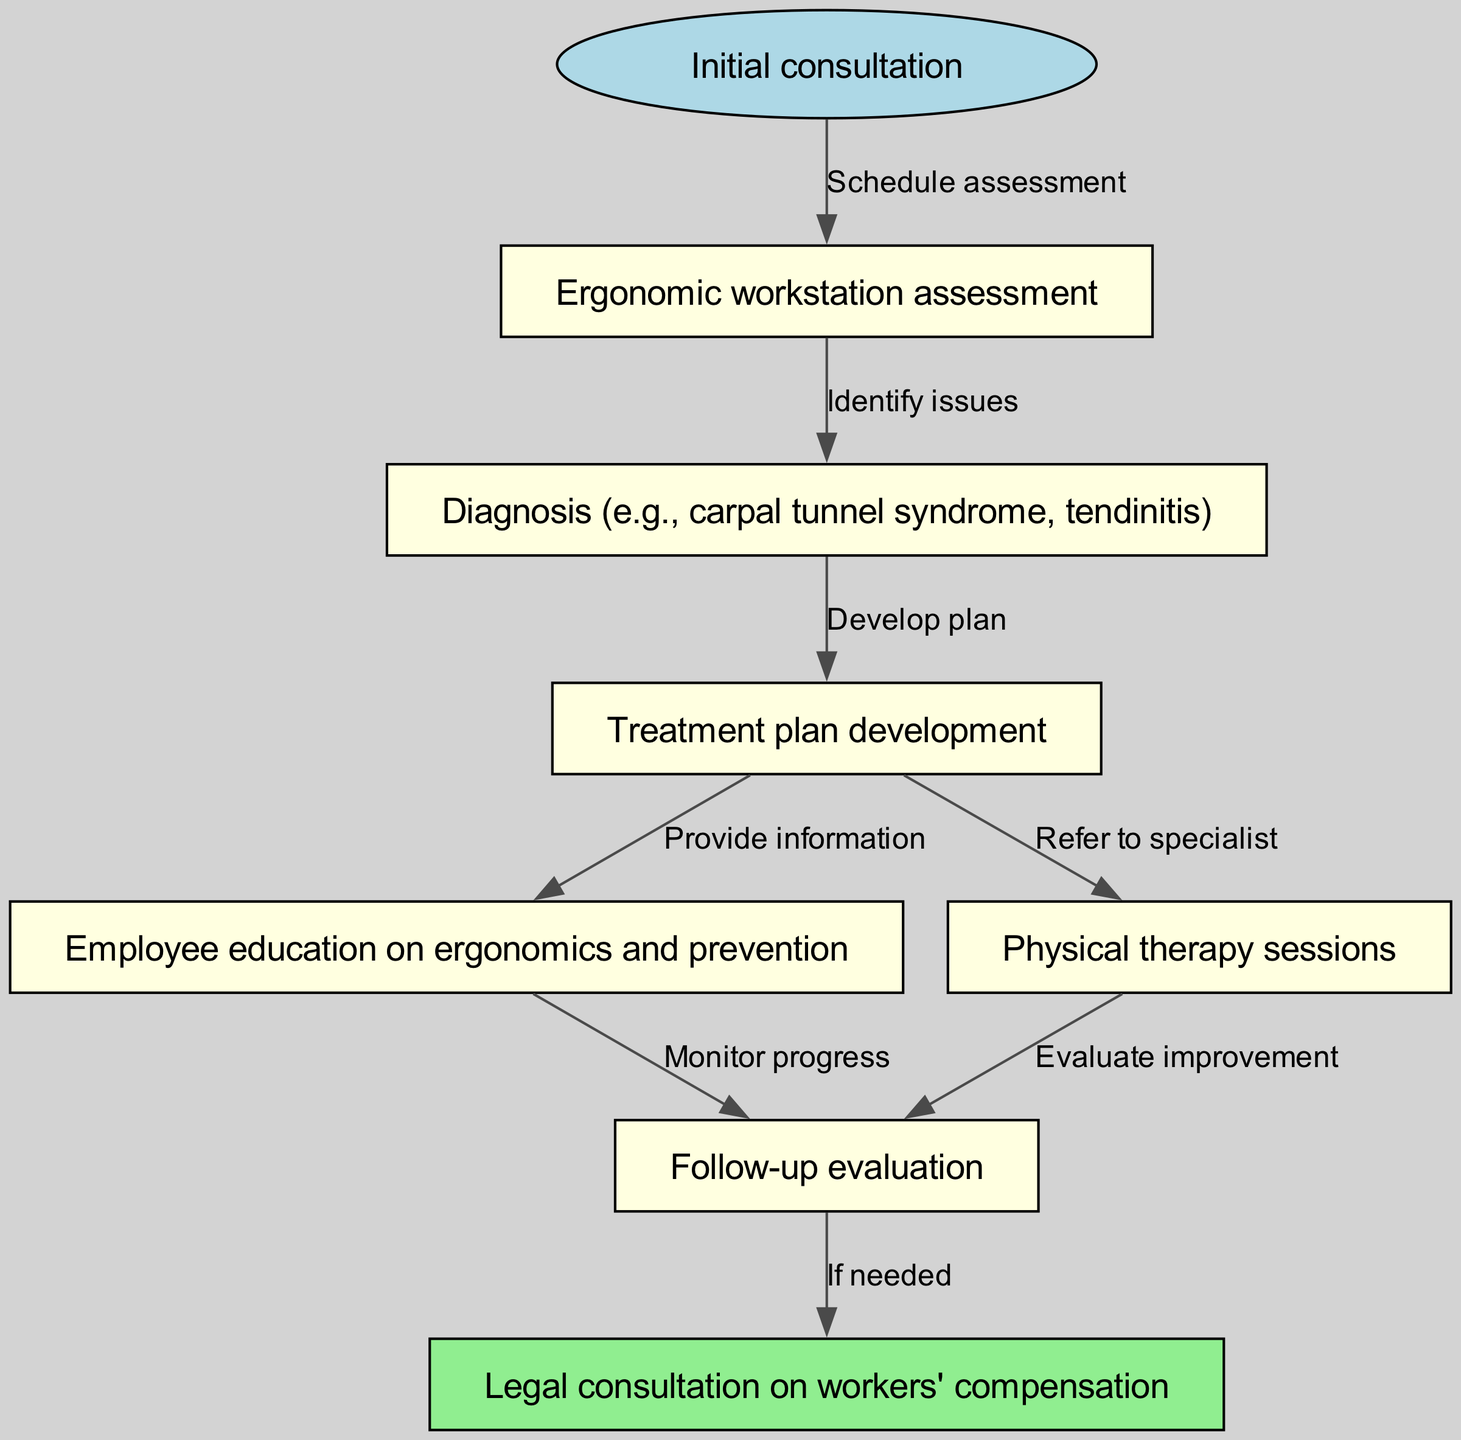What is the first step in the clinical pathway? The first step in the clinical pathway is labeled as "Initial consultation". This is indicated as the starting point in the diagram with an oval shape representing it.
Answer: Initial consultation How many nodes are in the clinical pathway? There are a total of seven nodes listed in the diagram. Each node represents a key step in the care process for repetitive strain injuries.
Answer: 7 What step follows the "Ergonomic workstation assessment"? After the "Ergonomic workstation assessment", the next step is "Diagnosis". This can be seen from the directed edge that flows from the assessment node to the diagnosis node in the pathway.
Answer: Diagnosis What is the purpose of the "Legal consultation on workers' compensation" node? The node "Legal consultation on workers' compensation" serves as an optional follow-up for legal advice if needed after evaluating progress in the previous steps. This indicates the pathway allows for legal considerations after health assessments and treatments.
Answer: If needed How does "Physical therapy sessions" connect to "Follow-up evaluation"? The "Physical therapy sessions" node connects to "Follow-up evaluation" via a direct edge that indicates an evaluation of improvement after physical therapy has taken place. This showcases the progression towards assessing recovery from repetitive strain injuries.
Answer: Evaluate improvement What action is suggested after developing a treatment plan? After developing a treatment plan, the next actions suggested include providing information to the employee through education on ergonomics and prevention, and possibly referring them to a specialist for physical therapy. This reflects a multi-faceted approach to treatment following diagnosis.
Answer: Provide information; Refer to specialist What is the relationship between "Education" and "Follow-up evaluation"? The relationship between "Education" and "Follow-up evaluation" is direct, indicated by an edge that shows "Monitor progress" as the action taken after the education step. This implies that monitoring is essential for evaluating the effectiveness of the education on reducing injuries.
Answer: Monitor progress 